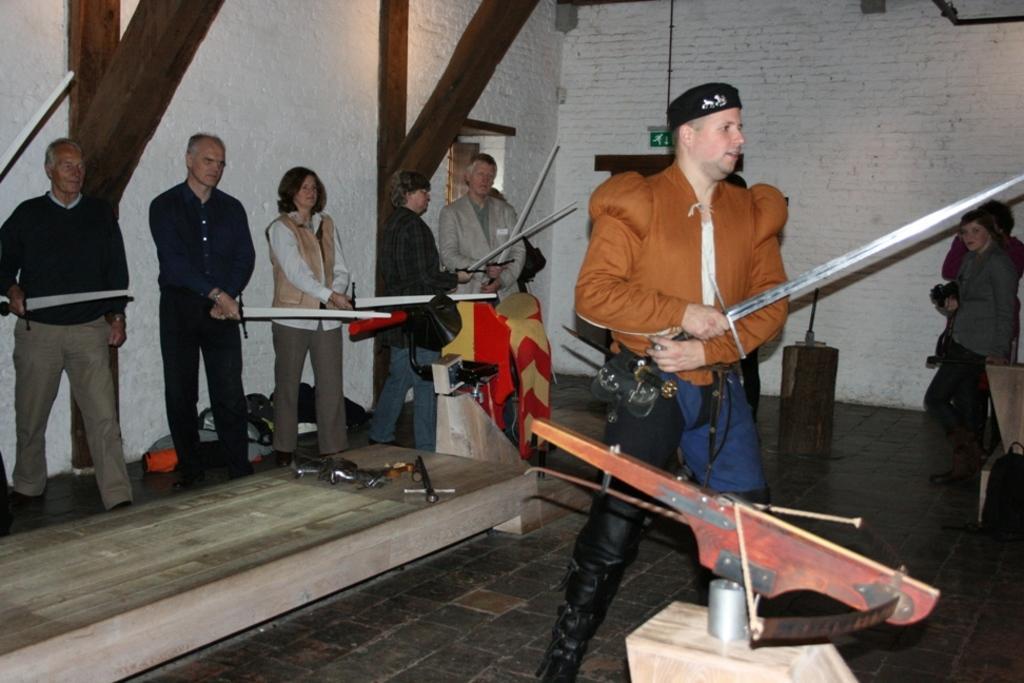How would you summarize this image in a sentence or two? In this picture I can see there is a man standing at right is holding a sword and there are few others in backdrop they are also holding a sword and there is a bow here. There are wooden frames in the backdrop and there are two others holding the camera on top right. 